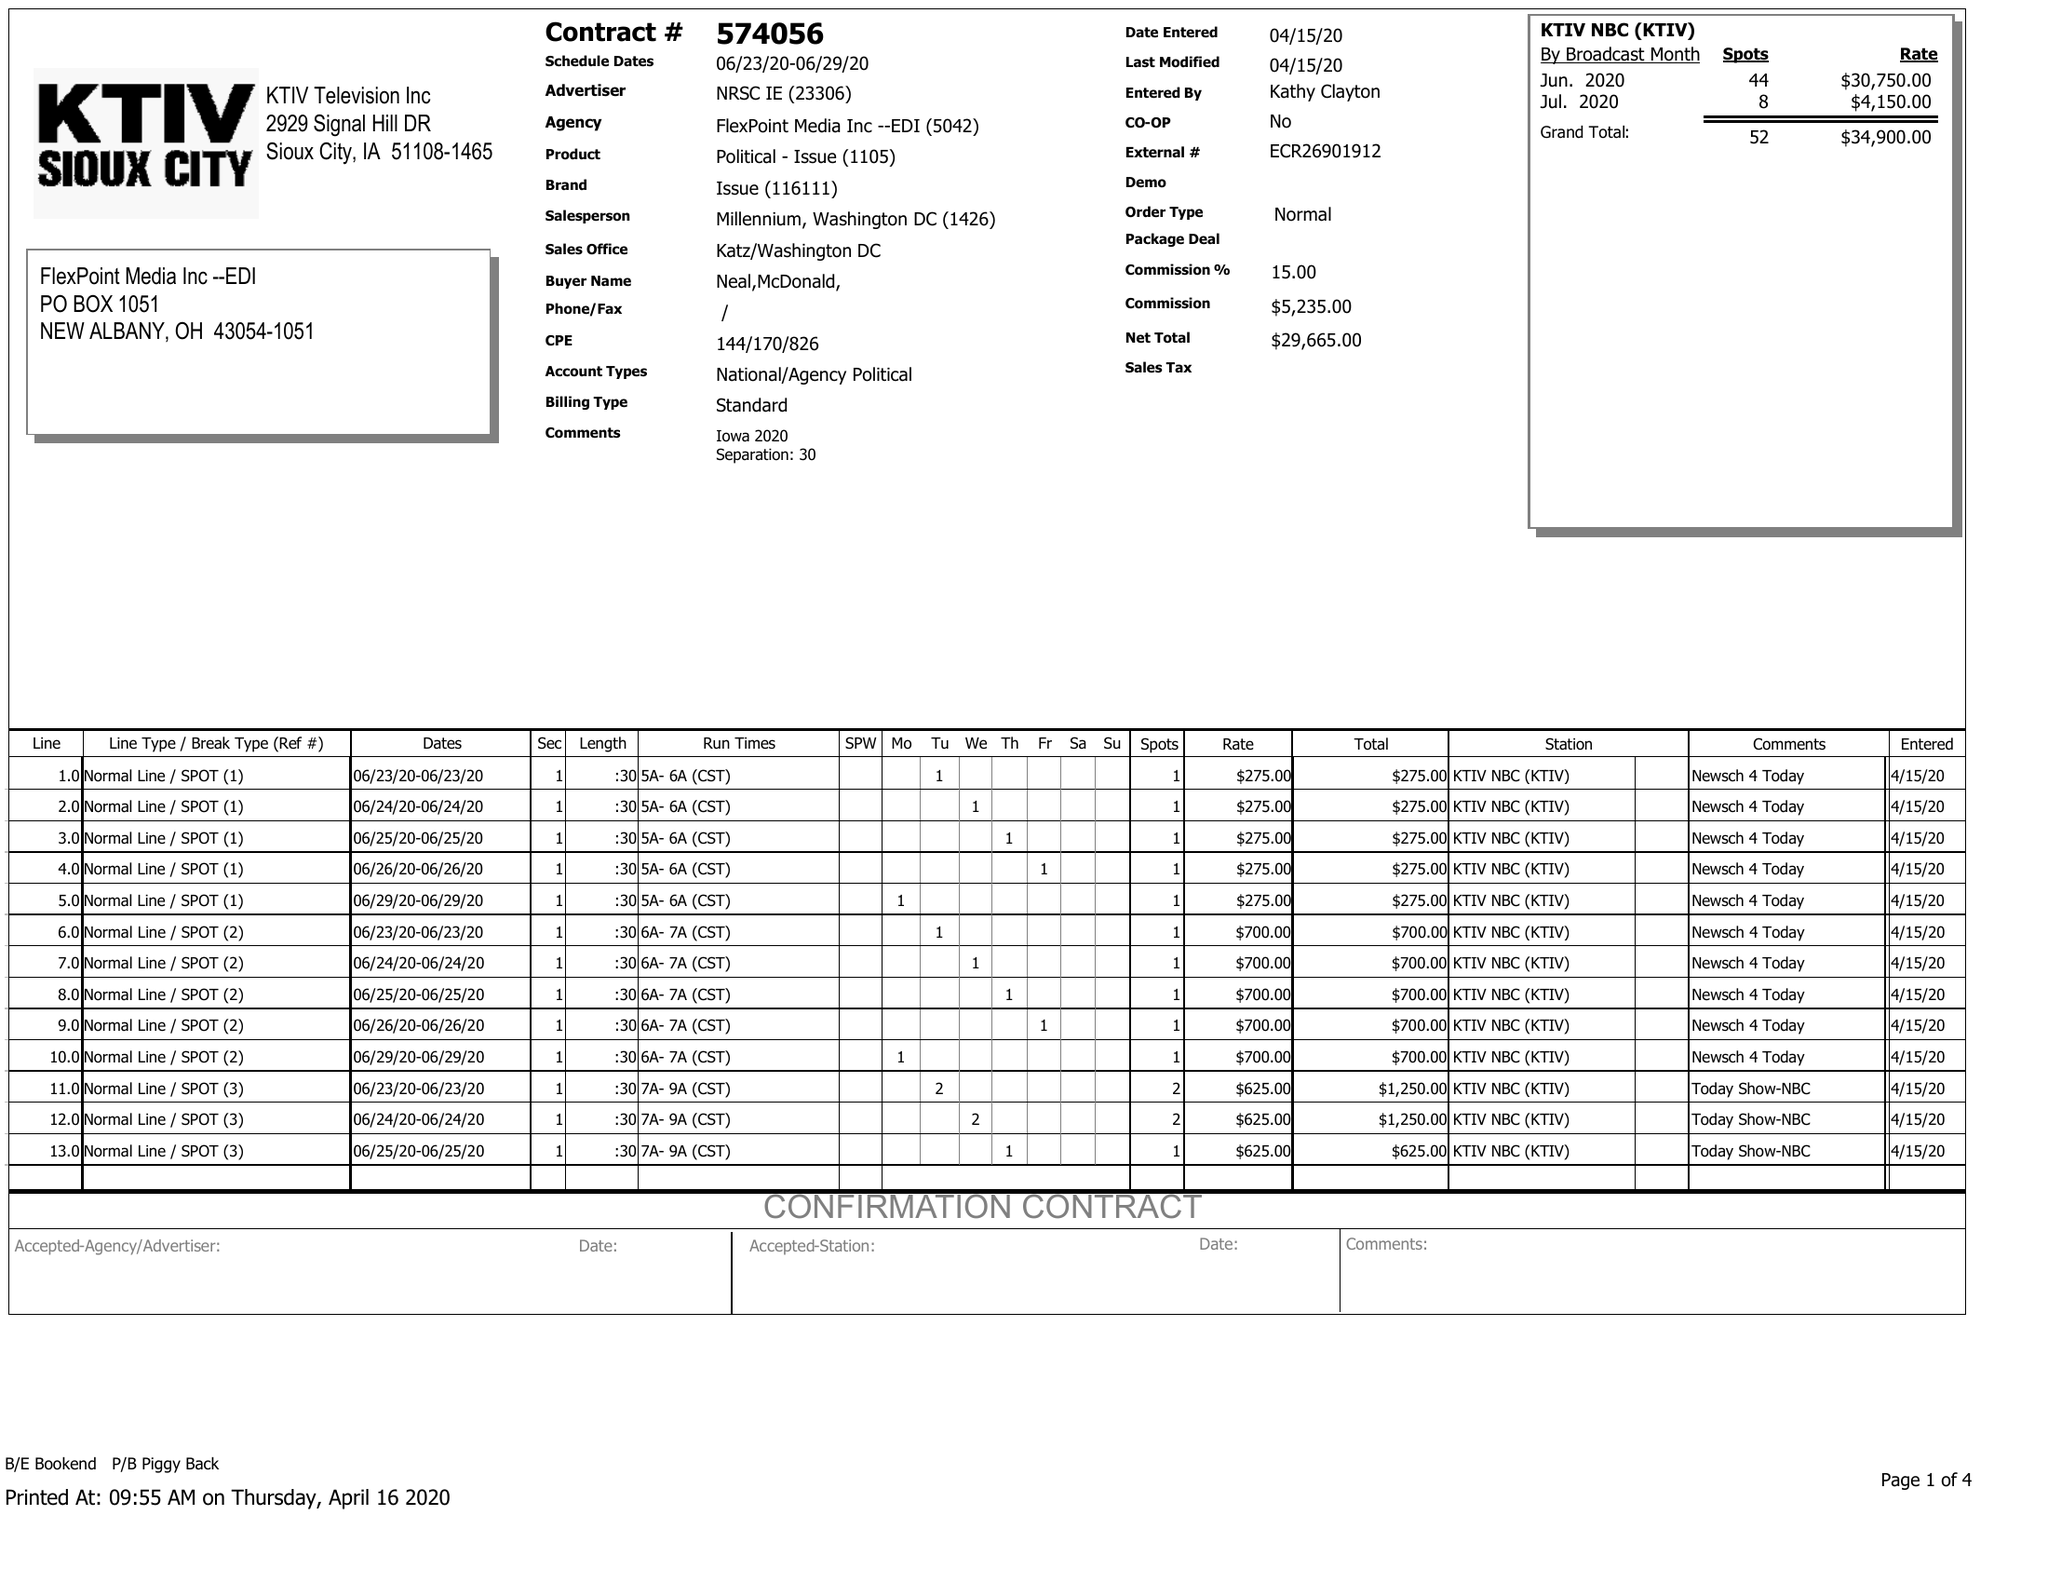What is the value for the flight_from?
Answer the question using a single word or phrase. 06/23/20 